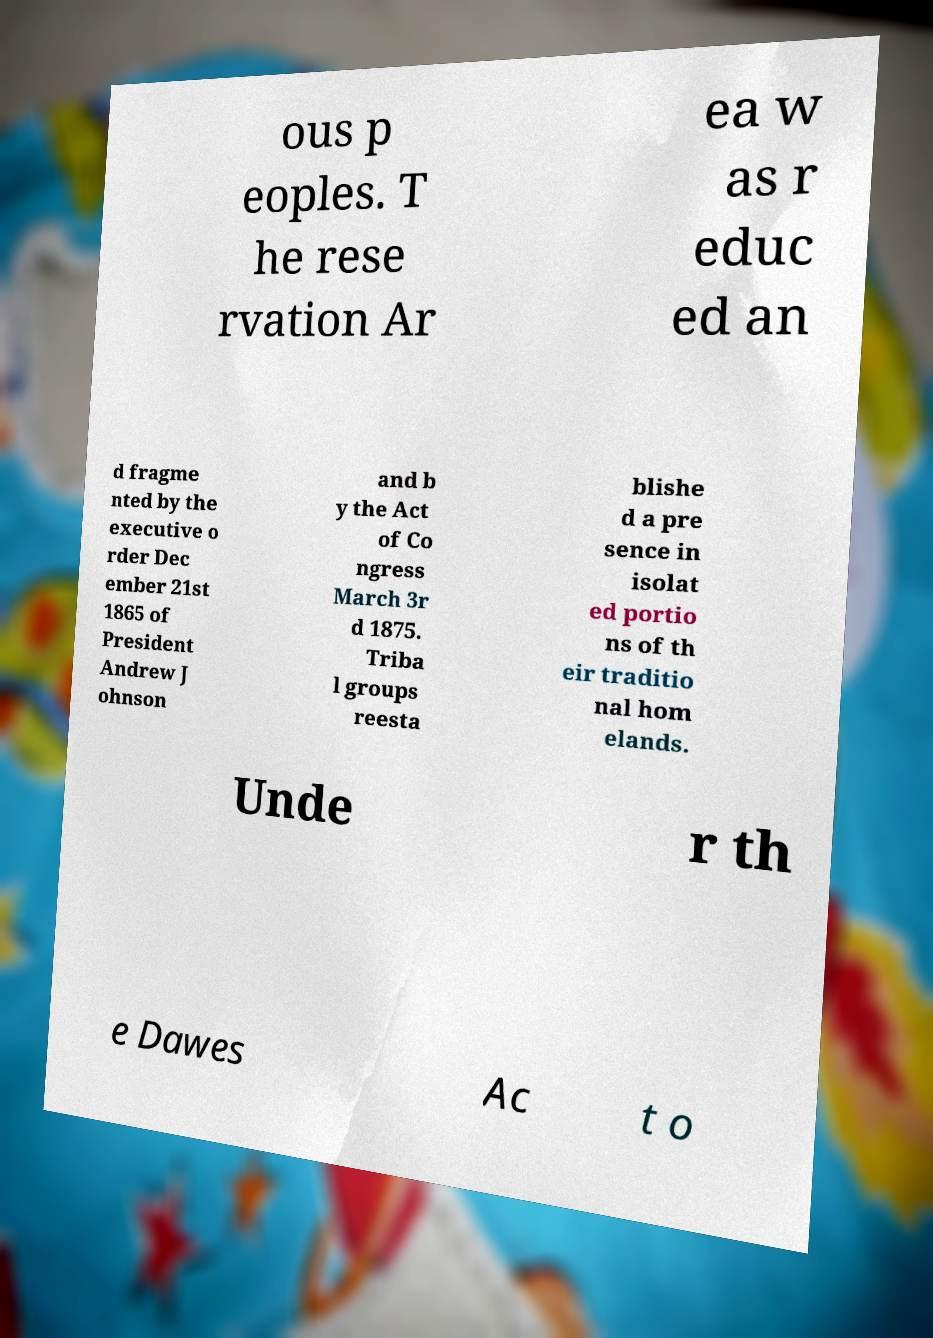Can you accurately transcribe the text from the provided image for me? ous p eoples. T he rese rvation Ar ea w as r educ ed an d fragme nted by the executive o rder Dec ember 21st 1865 of President Andrew J ohnson and b y the Act of Co ngress March 3r d 1875. Triba l groups reesta blishe d a pre sence in isolat ed portio ns of th eir traditio nal hom elands. Unde r th e Dawes Ac t o 